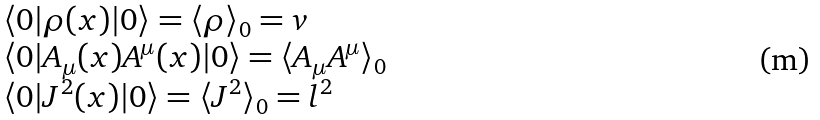<formula> <loc_0><loc_0><loc_500><loc_500>\begin{array} { l } { { \langle 0 | \rho ( x ) | 0 \rangle = \langle \rho \rangle _ { 0 } = v } } \\ { { \langle 0 | A _ { \mu } ( x ) A ^ { \mu } ( x ) | 0 \rangle = \langle A _ { \mu } A ^ { \mu } \rangle _ { 0 } } } \\ { { \langle 0 | J ^ { 2 } ( x ) | 0 \rangle = \langle J ^ { 2 } \rangle _ { 0 } = l ^ { 2 } } } \end{array}</formula> 